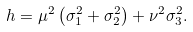<formula> <loc_0><loc_0><loc_500><loc_500>h = \mu ^ { 2 } \left ( \sigma _ { 1 } ^ { 2 } + \sigma _ { 2 } ^ { 2 } \right ) + \nu ^ { 2 } \sigma _ { 3 } ^ { 2 } .</formula> 